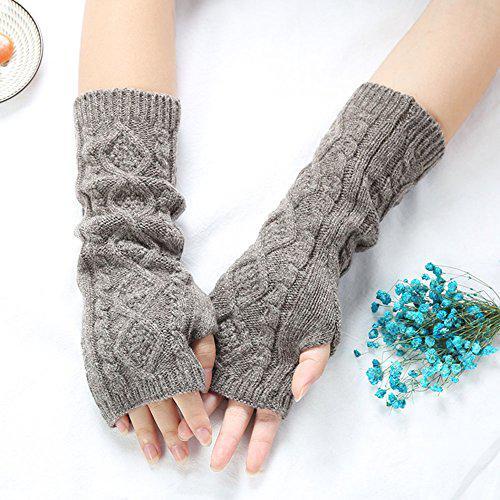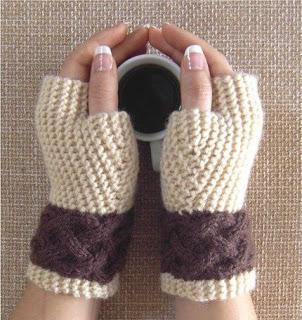The first image is the image on the left, the second image is the image on the right. Assess this claim about the two images: "One image shows half mittens that leave all fingers exposed and are made of one color of yarn, and the other image contains a half mitten with at least one button.". Correct or not? Answer yes or no. No. The first image is the image on the left, the second image is the image on the right. For the images displayed, is the sentence "The left and right image contains the same number of sets of fingerless mittens." factually correct? Answer yes or no. Yes. 